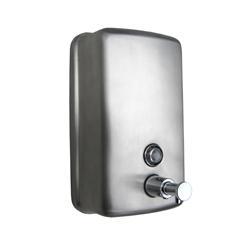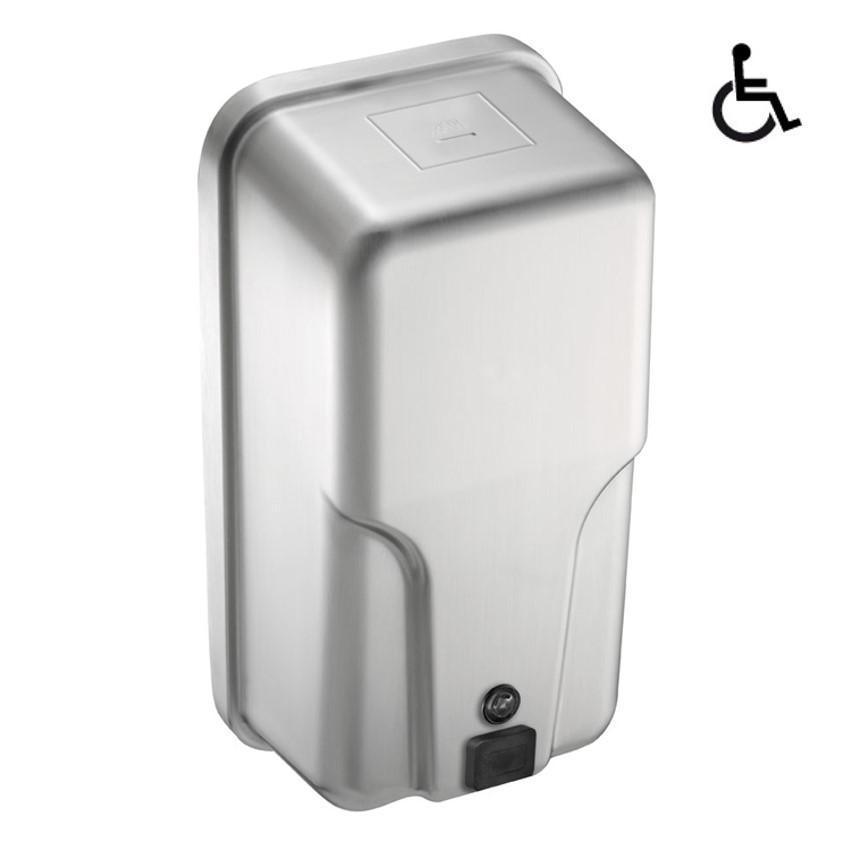The first image is the image on the left, the second image is the image on the right. Considering the images on both sides, is "The dispenser on the left has a chrome push-button that extends out, and the dispenser on the right has a flat black rectangular button." valid? Answer yes or no. Yes. 